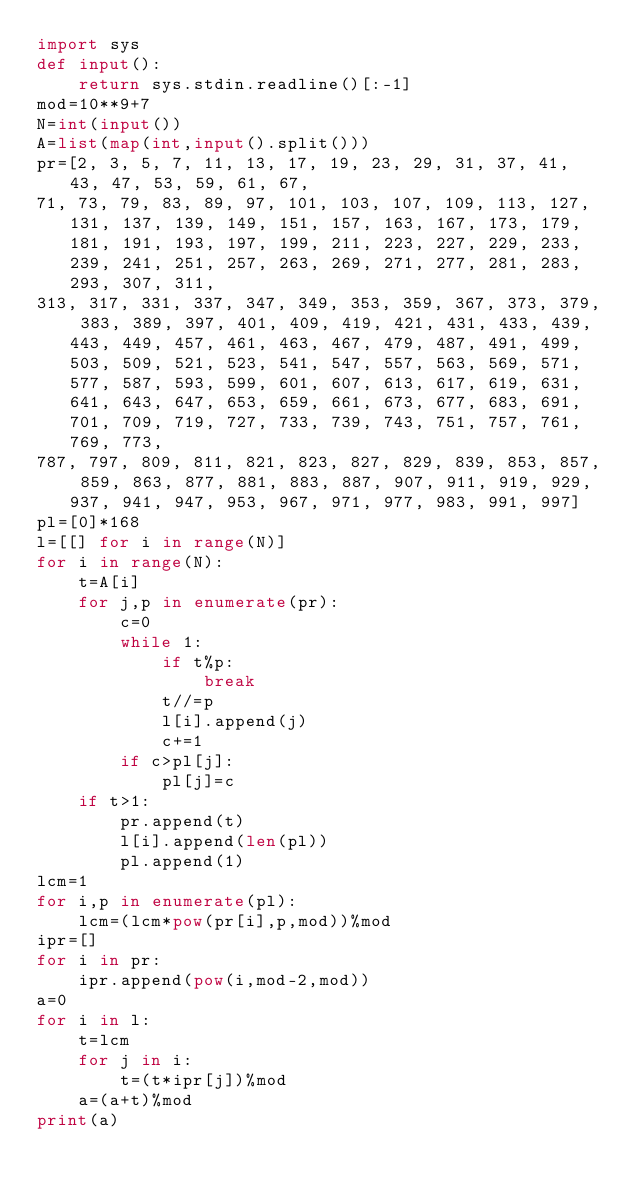Convert code to text. <code><loc_0><loc_0><loc_500><loc_500><_Python_>import sys
def input():
    return sys.stdin.readline()[:-1]
mod=10**9+7
N=int(input())
A=list(map(int,input().split()))
pr=[2, 3, 5, 7, 11, 13, 17, 19, 23, 29, 31, 37, 41, 43, 47, 53, 59, 61, 67, 
71, 73, 79, 83, 89, 97, 101, 103, 107, 109, 113, 127, 131, 137, 139, 149, 151, 157, 163, 167, 173, 179, 181, 191, 193, 197, 199, 211, 223, 227, 229, 233, 239, 241, 251, 257, 263, 269, 271, 277, 281, 283, 293, 307, 311, 
313, 317, 331, 337, 347, 349, 353, 359, 367, 373, 379, 383, 389, 397, 401, 409, 419, 421, 431, 433, 439, 443, 449, 457, 461, 463, 467, 479, 487, 491, 499, 503, 509, 521, 523, 541, 547, 557, 563, 569, 571, 577, 587, 593, 599, 601, 607, 613, 617, 619, 631, 641, 643, 647, 653, 659, 661, 673, 677, 683, 691, 701, 709, 719, 727, 733, 739, 743, 751, 757, 761, 769, 773, 
787, 797, 809, 811, 821, 823, 827, 829, 839, 853, 857, 859, 863, 877, 881, 883, 887, 907, 911, 919, 929, 937, 941, 947, 953, 967, 971, 977, 983, 991, 997]
pl=[0]*168
l=[[] for i in range(N)]
for i in range(N):
    t=A[i]
    for j,p in enumerate(pr):
        c=0
        while 1:
            if t%p:
                break
            t//=p
            l[i].append(j)
            c+=1
        if c>pl[j]:
            pl[j]=c
    if t>1:
        pr.append(t)
        l[i].append(len(pl))
        pl.append(1)
lcm=1
for i,p in enumerate(pl):
    lcm=(lcm*pow(pr[i],p,mod))%mod
ipr=[]
for i in pr:
    ipr.append(pow(i,mod-2,mod))
a=0
for i in l:
    t=lcm
    for j in i:
        t=(t*ipr[j])%mod
    a=(a+t)%mod
print(a)</code> 